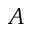Convert formula to latex. <formula><loc_0><loc_0><loc_500><loc_500>A</formula> 